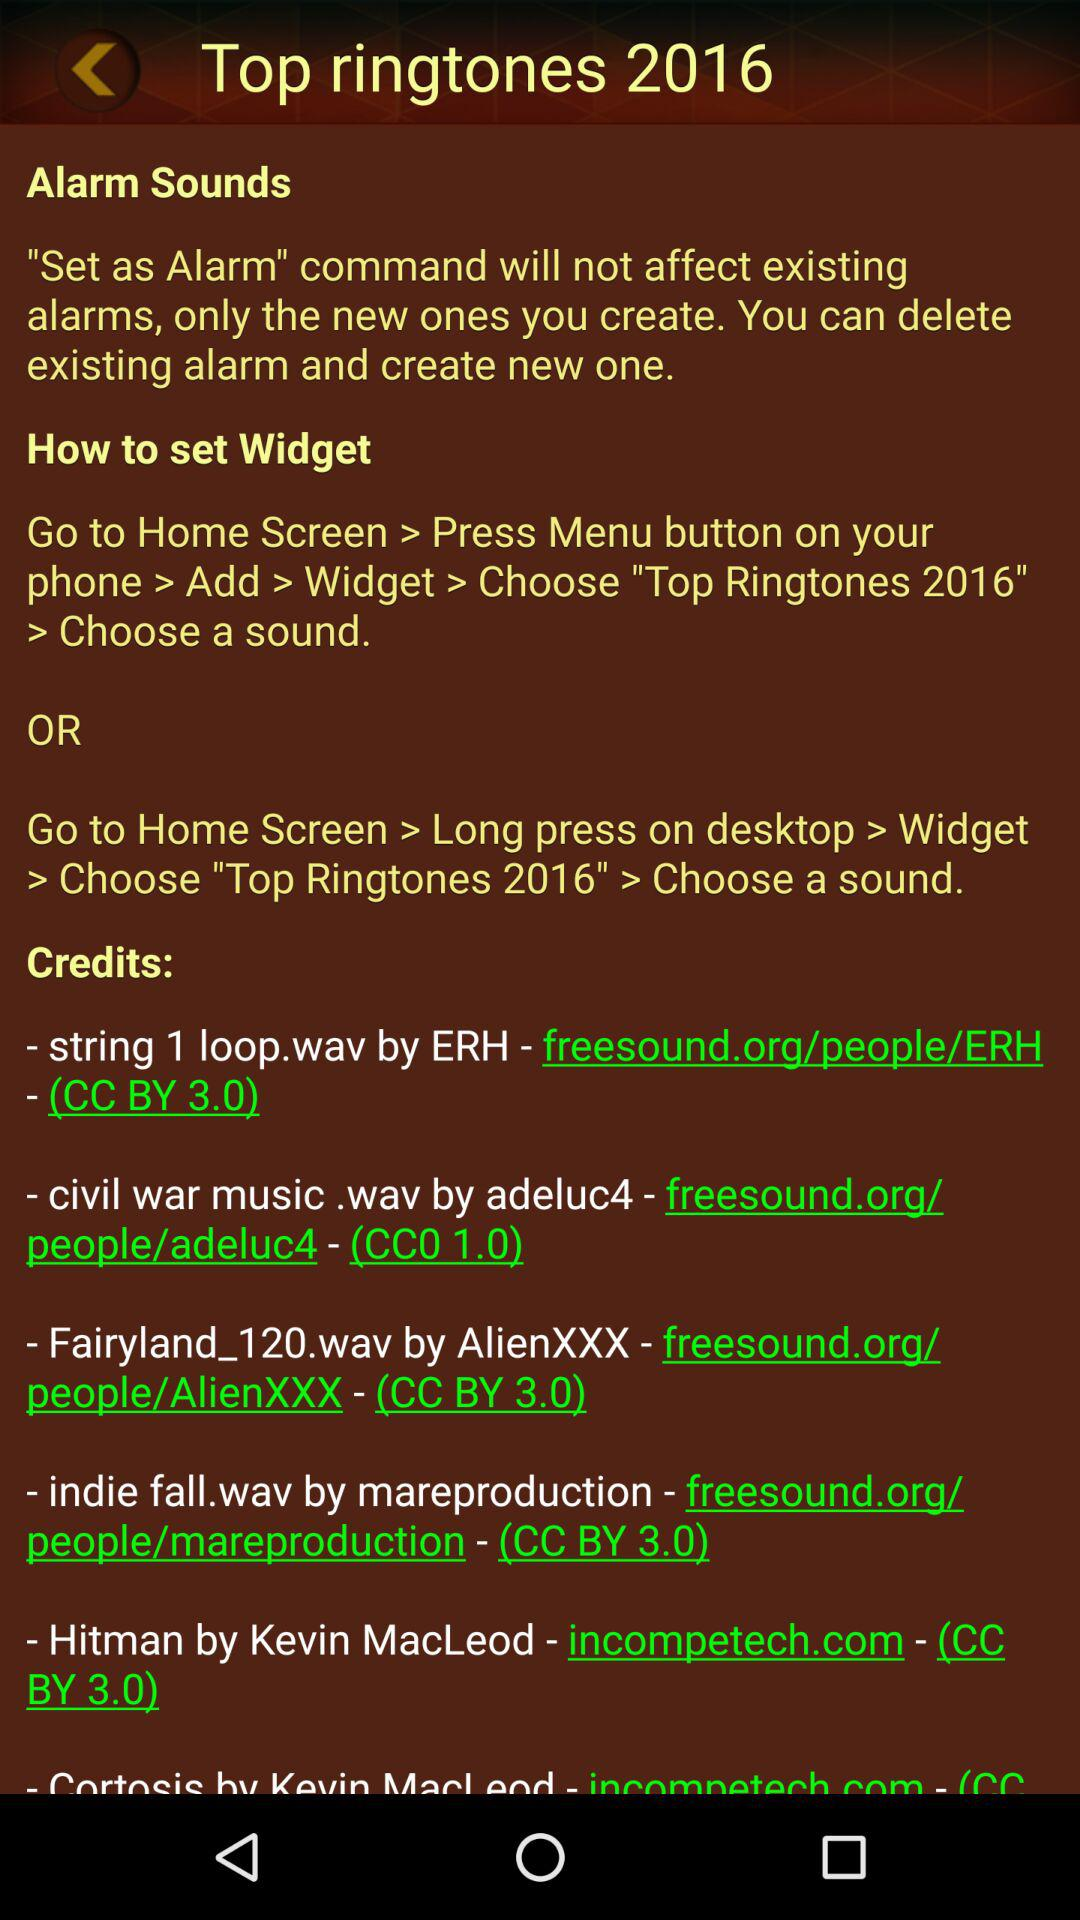How many sound credits are there?
Answer the question using a single word or phrase. 6 